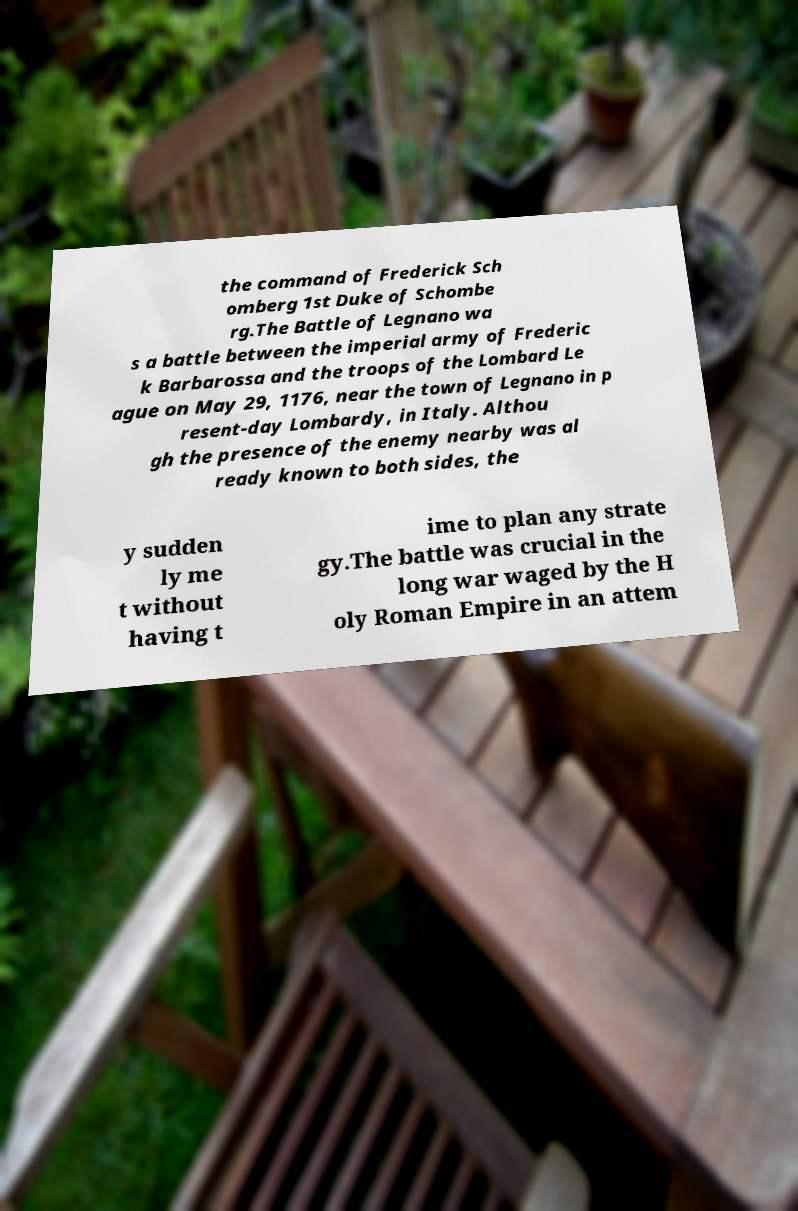Could you extract and type out the text from this image? the command of Frederick Sch omberg 1st Duke of Schombe rg.The Battle of Legnano wa s a battle between the imperial army of Frederic k Barbarossa and the troops of the Lombard Le ague on May 29, 1176, near the town of Legnano in p resent-day Lombardy, in Italy. Althou gh the presence of the enemy nearby was al ready known to both sides, the y sudden ly me t without having t ime to plan any strate gy.The battle was crucial in the long war waged by the H oly Roman Empire in an attem 